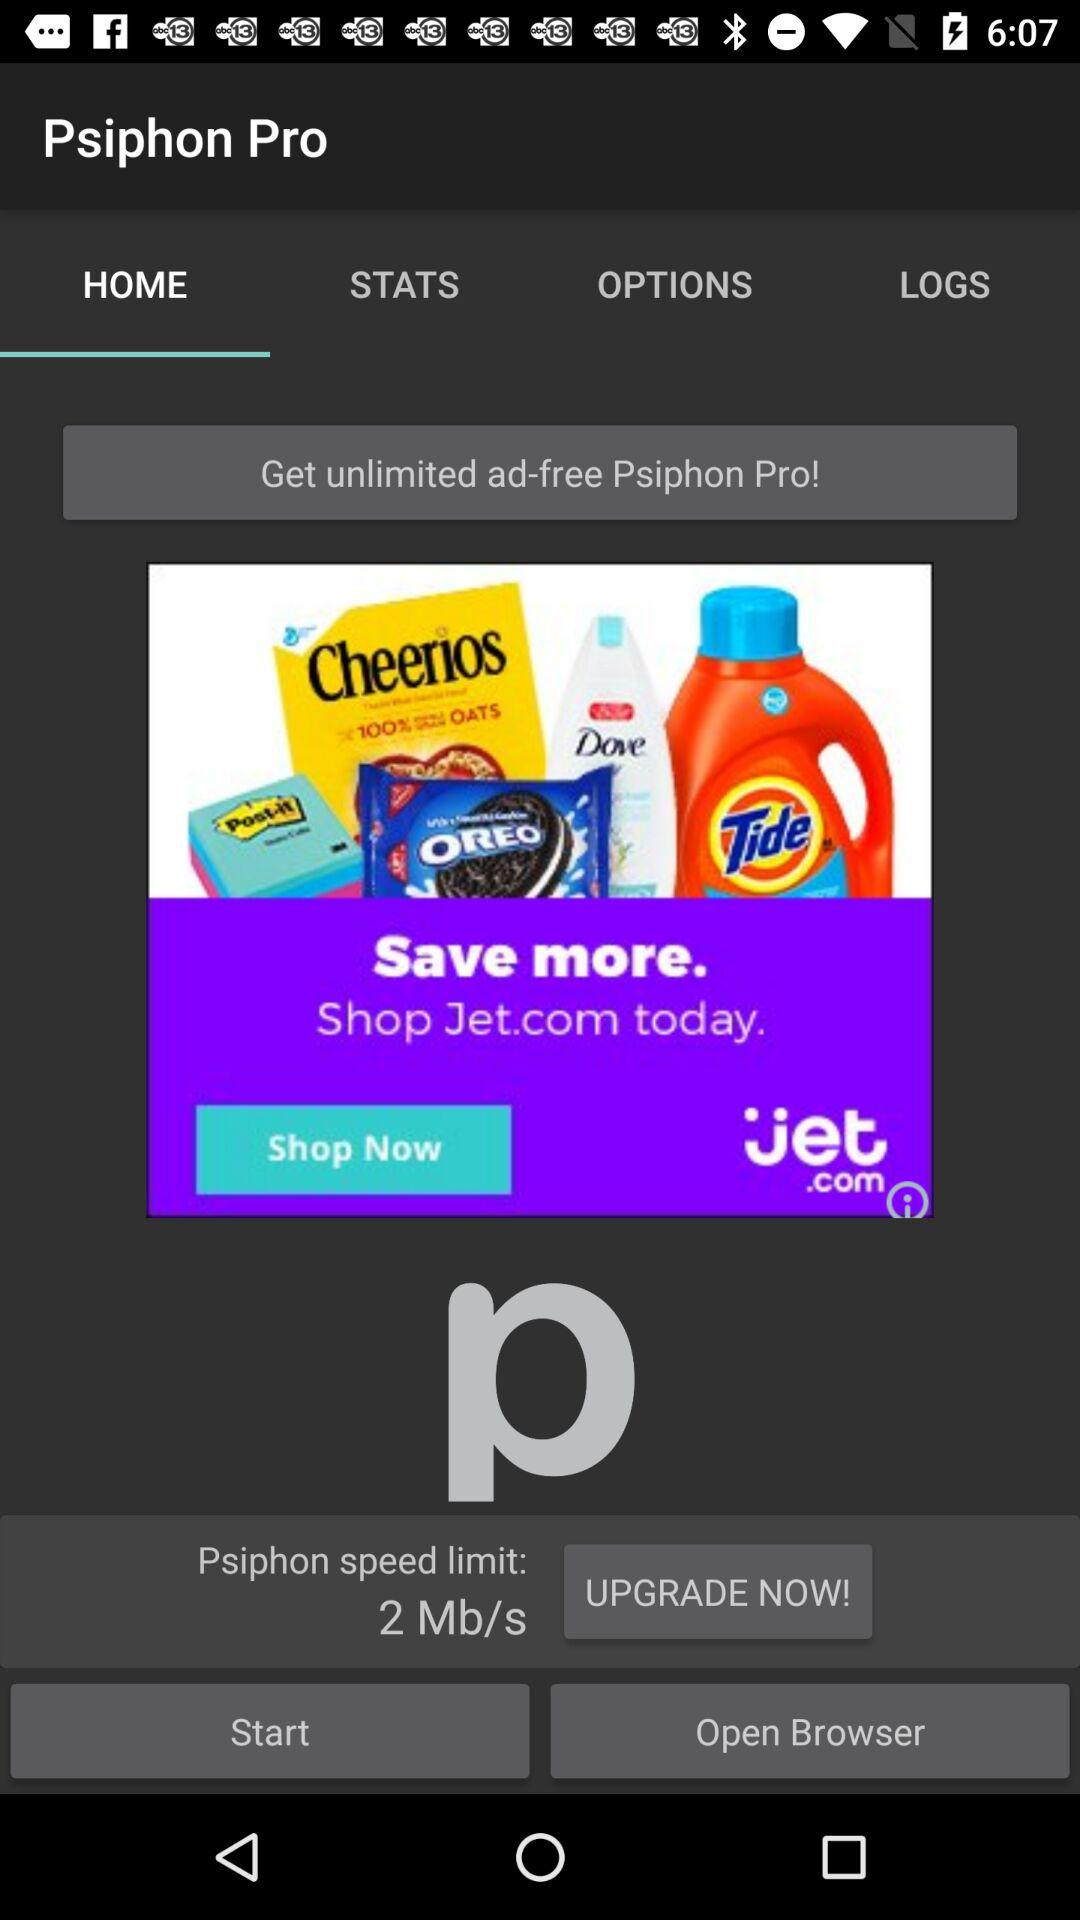What is the application name? The application name is "Psiphon Pro". 